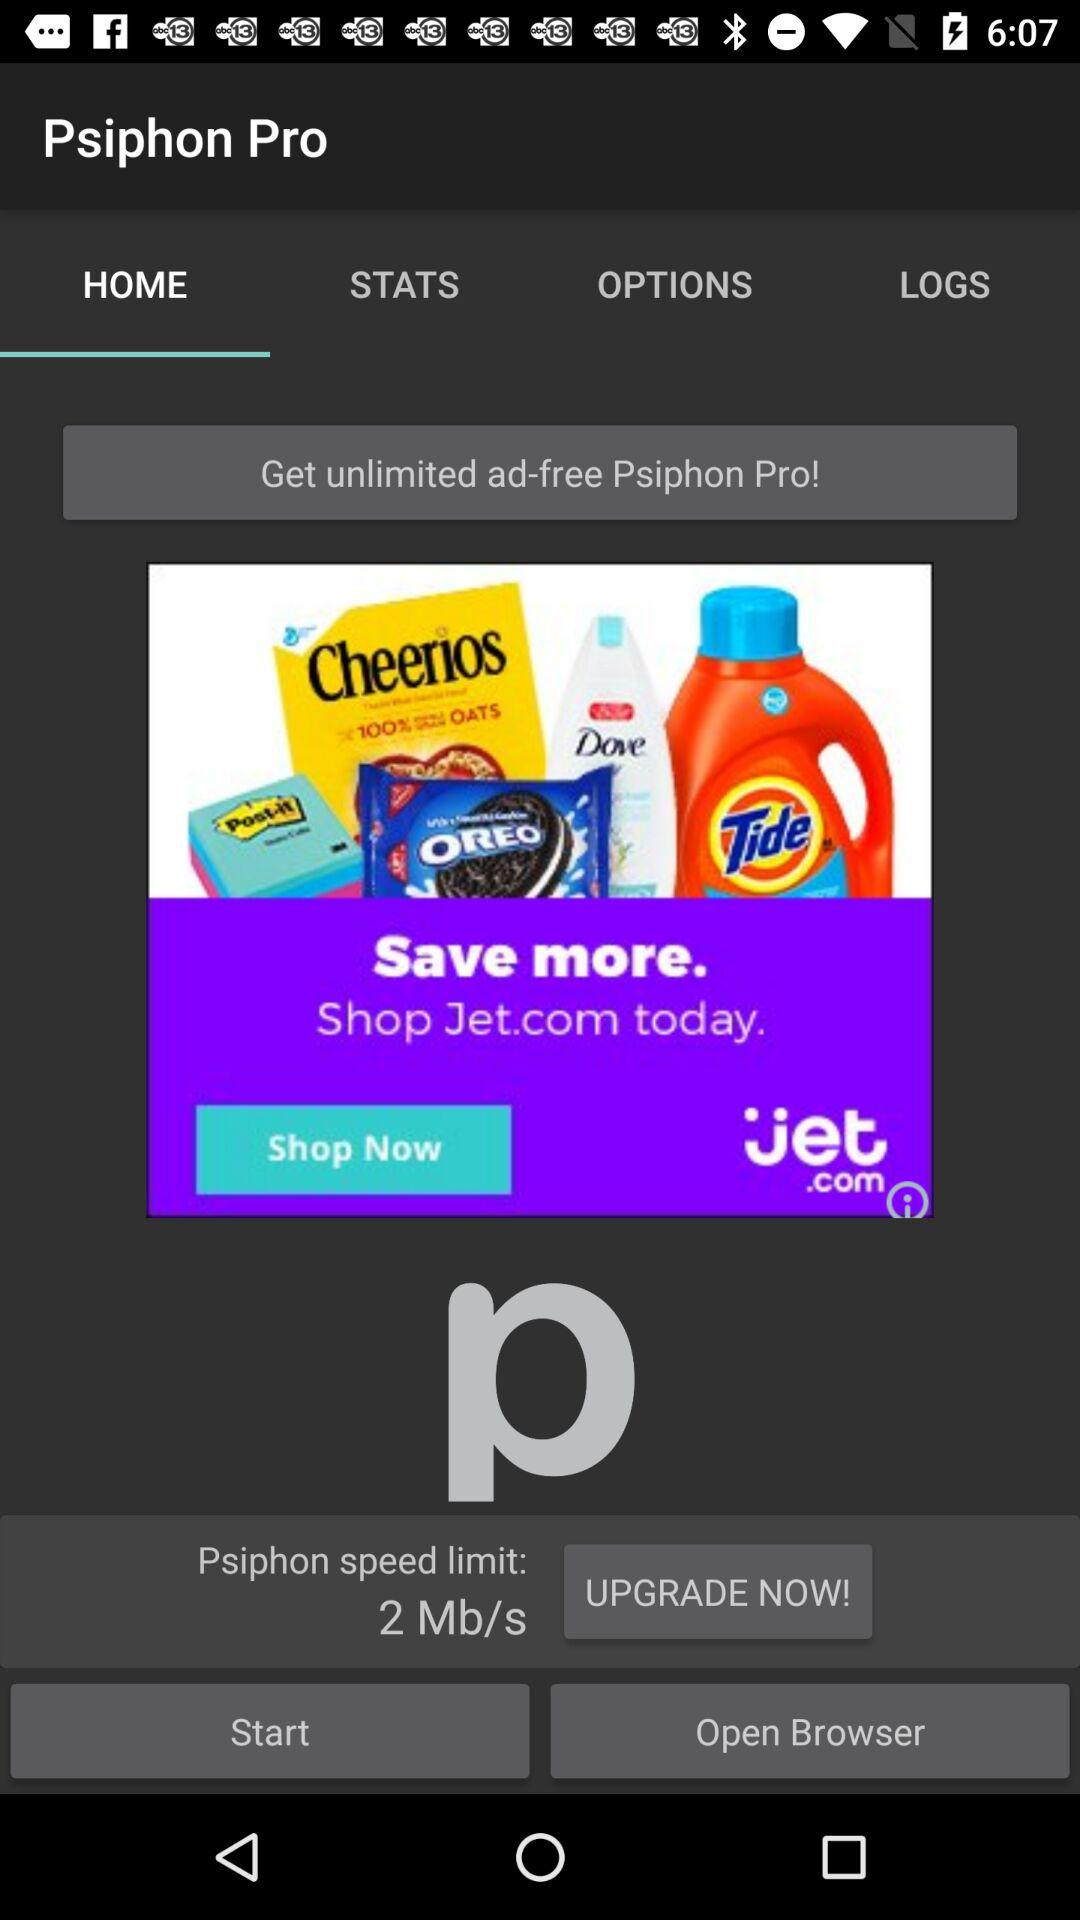What is the application name? The application name is "Psiphon Pro". 